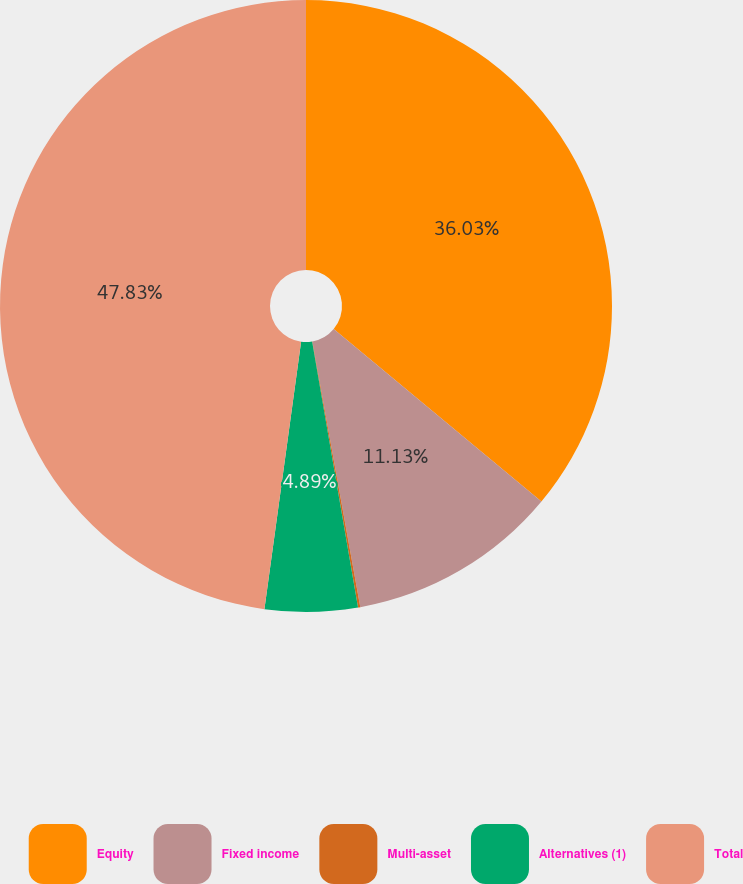<chart> <loc_0><loc_0><loc_500><loc_500><pie_chart><fcel>Equity<fcel>Fixed income<fcel>Multi-asset<fcel>Alternatives (1)<fcel>Total<nl><fcel>36.03%<fcel>11.13%<fcel>0.12%<fcel>4.89%<fcel>47.83%<nl></chart> 